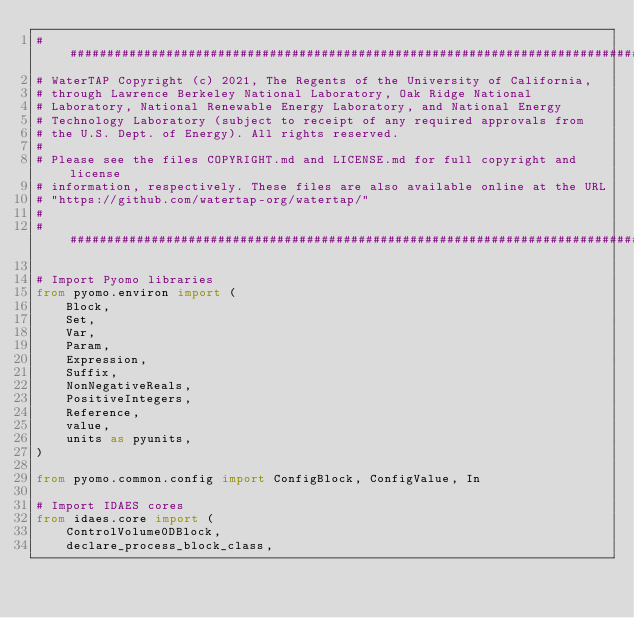Convert code to text. <code><loc_0><loc_0><loc_500><loc_500><_Python_>###############################################################################
# WaterTAP Copyright (c) 2021, The Regents of the University of California,
# through Lawrence Berkeley National Laboratory, Oak Ridge National
# Laboratory, National Renewable Energy Laboratory, and National Energy
# Technology Laboratory (subject to receipt of any required approvals from
# the U.S. Dept. of Energy). All rights reserved.
#
# Please see the files COPYRIGHT.md and LICENSE.md for full copyright and license
# information, respectively. These files are also available online at the URL
# "https://github.com/watertap-org/watertap/"
#
###############################################################################

# Import Pyomo libraries
from pyomo.environ import (
    Block,
    Set,
    Var,
    Param,
    Expression,
    Suffix,
    NonNegativeReals,
    PositiveIntegers,
    Reference,
    value,
    units as pyunits,
)

from pyomo.common.config import ConfigBlock, ConfigValue, In

# Import IDAES cores
from idaes.core import (
    ControlVolume0DBlock,
    declare_process_block_class,</code> 